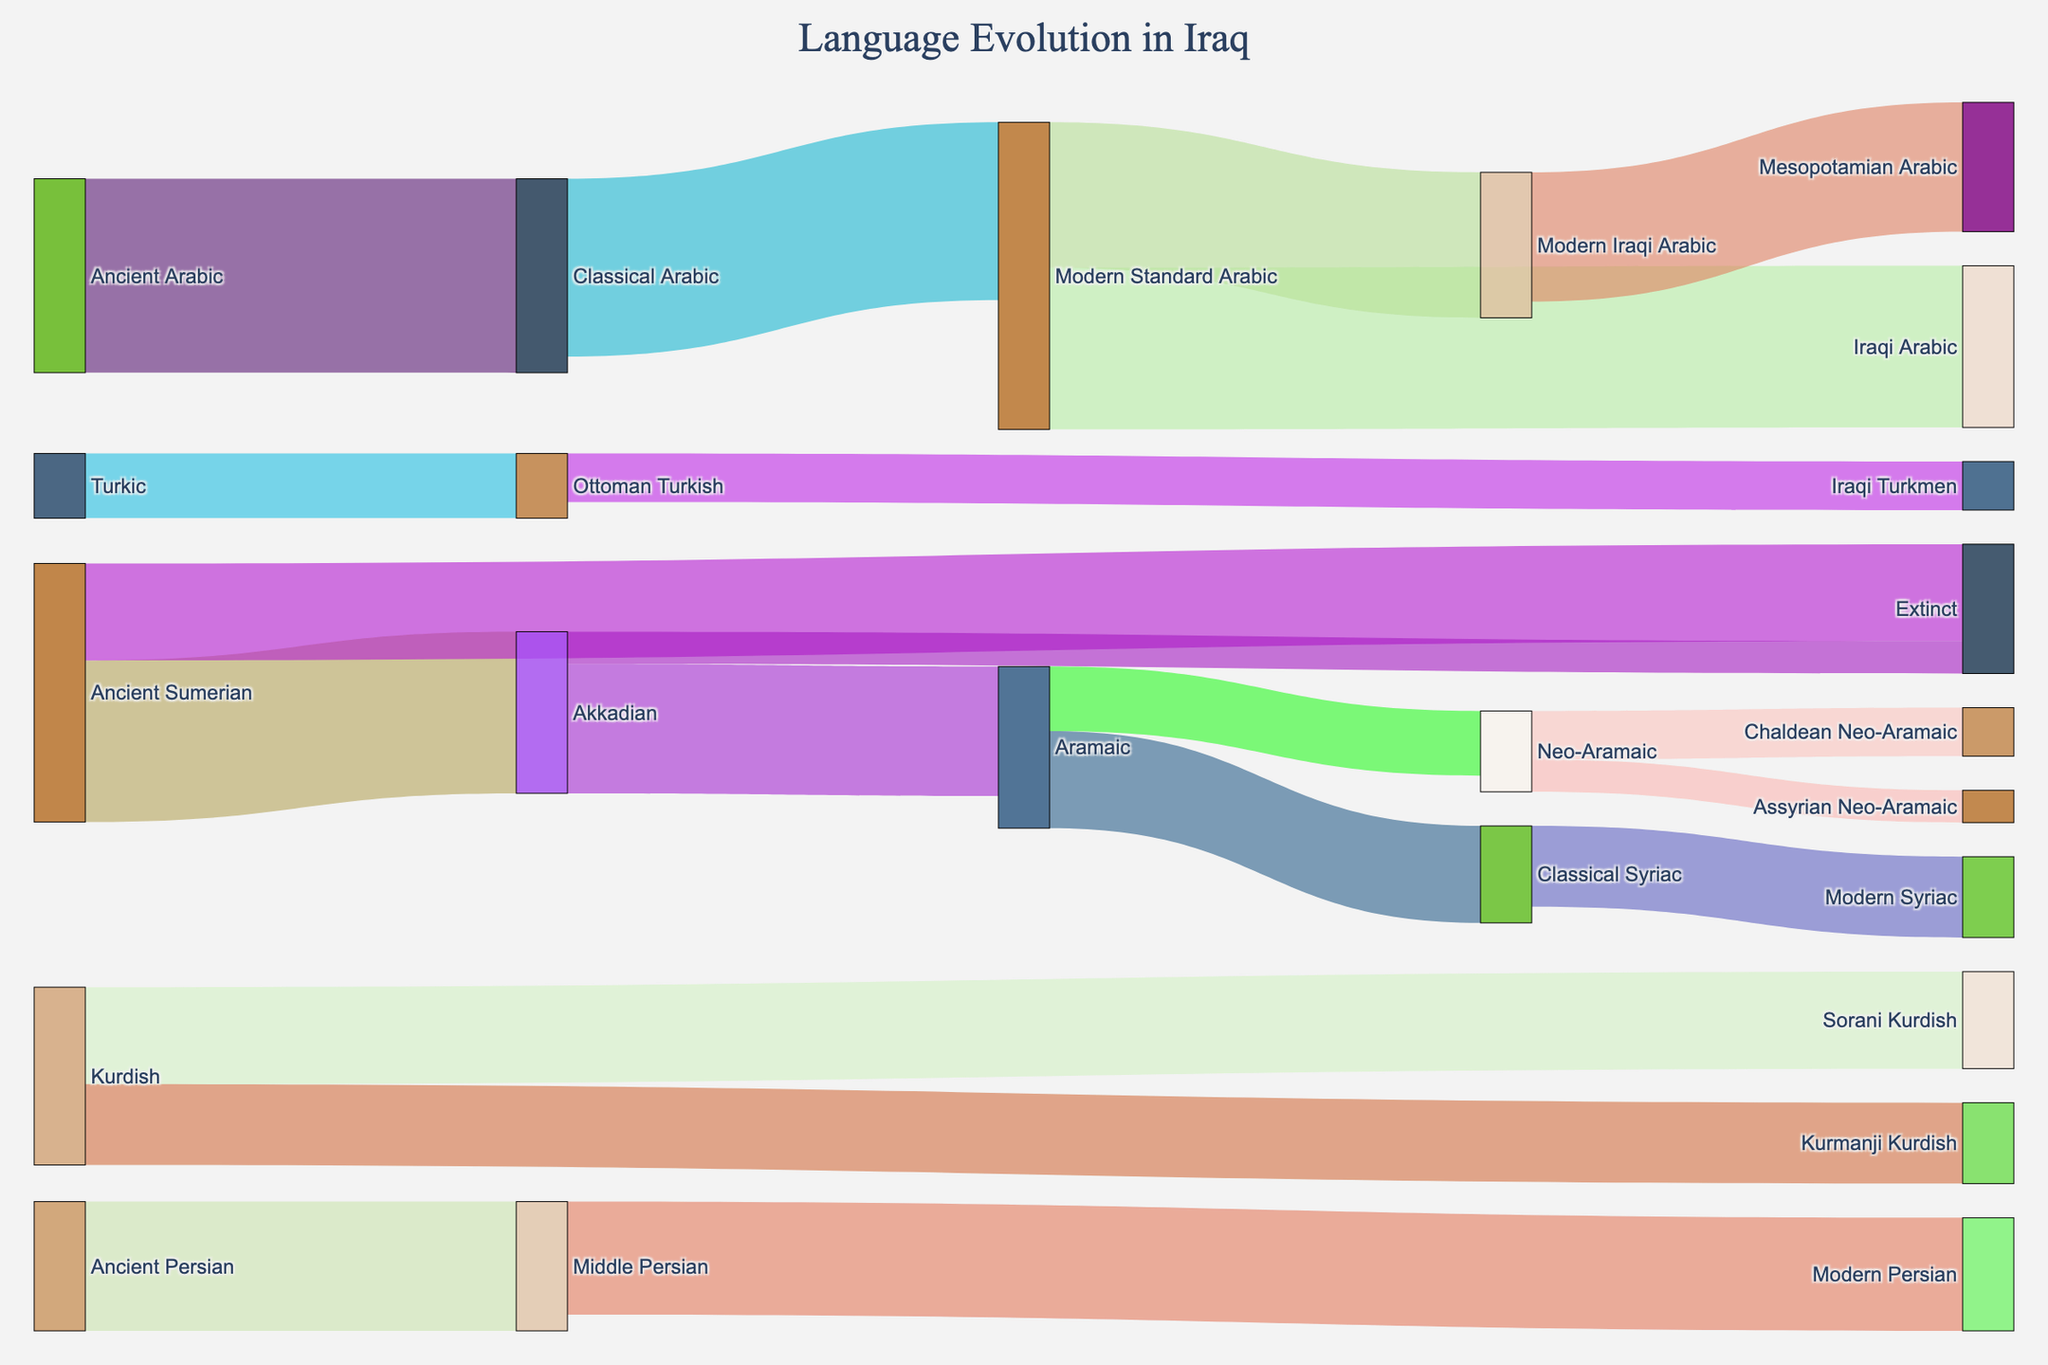What is the title of the figure? The title is usually placed at the top of the figure. By reading the top center of the figure, one can see the title "Language Evolution in Iraq".
Answer: Language Evolution in Iraq Which ancient language has the largest number of descendants in the Sankey Diagram? By observing the figure, we see that "Ancient Arabic" flows into "Classical Arabic" with a value of 60, making it the ancient language with the largest number of descendants.
Answer: Ancient Arabic How many modern languages have evolved from "Modern Standard Arabic"? To determine this, look at all the targets that "Modern Standard Arabic" flows into in the diagram; these are "Iraqi Arabic" and "Modern Iraqi Arabic" with values of 50 and 45 respectively. There are two modern languages.
Answer: 2 Which ancient language has the least influence, according to the diagram? The "Ancient Sumerian" has a flow of 30 to "Extinct," indicating it has become extinct significantly, losing its influence in comparison to other languages like "Ancient Arabic" or "Ancient Persian".
Answer: Ancient Sumerian What path does "Ancient Persian" follow to become "Modern Persian"? Starting from "Ancient Persian", follow the flows which lead to "Middle Persian" and from there to "Modern Persian".
Answer: Ancient Persian -> Middle Persian -> Modern Persian Compare the flows from "Akkadian" to its descendants. Which path has the largest flow and how much is it? By examining "Akkadian", it flows into "Aramaic" with a value of 40 and to "Extinct" with a value of 10. Thus, the largest flow path is to "Aramaic" with a value of 40.
Answer: Aramaic, 40 How many steps are there in the evolutionary path from "Ancient Arabic" to "Iraqi Arabic"? The path from "Ancient Arabic" to "Iraqi Arabic" involves three steps: "Ancient Arabic" -> "Classical Arabic" -> "Modern Standard Arabic" -> "Iraqi Arabic".
Answer: 3 Which language has the most diverse evolution paths coming out of it? By looking at the targets for each source, "Modern Standard Arabic" flows into "Iraqi Arabic" and "Modern Iraqi Arabic", showing it has multiple diverse paths.
Answer: Modern Standard Arabic What is the cumulative flow value that directly or indirectly comes from "Akkadian"? Sum the values from "Akkadian" to all its descendant paths: 40 (to Aramaic) + 30 (from Aramaic to Classical Syriac) + 25 (from Classical Syriac to Modern Syriac) + 20 (from Aramaic to Neo-Aramaic) + 15 (from Neo-Aramaic to Chaldean Neo-Aramaic) + 10 (from Neo-Aramaic to Assyrian Neo-Aramaic) + 10 (to extinct) = 140.
Answer: 140 